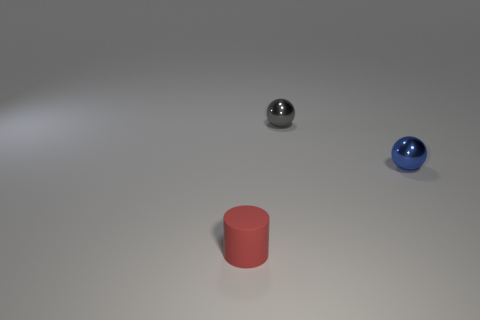Are the objects arranged in a particular pattern? The objects are not arranged in a clear, intentional pattern; they are placed at distances from one another without any discernible regularity or symmetry. 